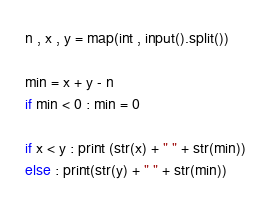Convert code to text. <code><loc_0><loc_0><loc_500><loc_500><_Python_>n , x , y = map(int , input().split())

min = x + y - n
if min < 0 : min = 0

if x < y : print (str(x) + " " + str(min))
else : print(str(y) + " " + str(min))</code> 